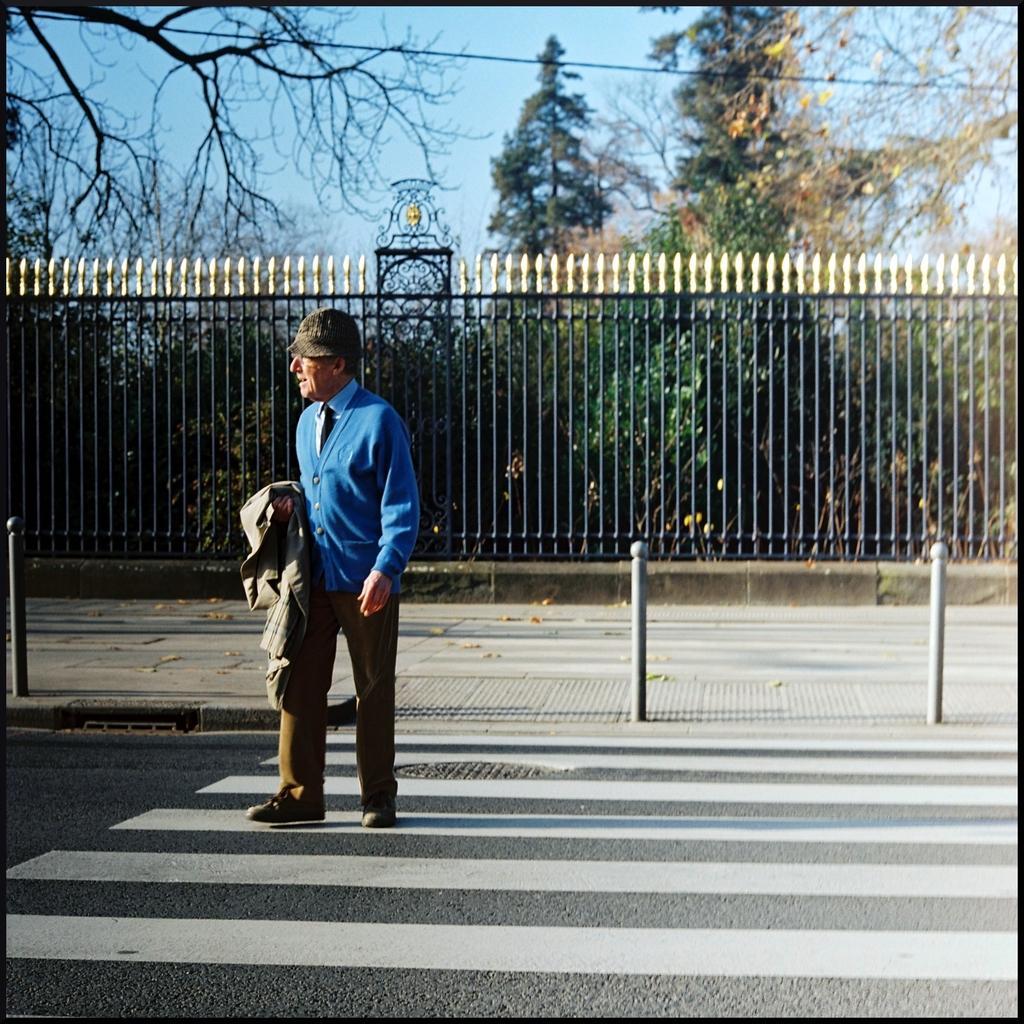Describe this image in one or two sentences. In the middle I can see a person on the road. In the background I can see a fence, trees and wires. On the top I can see the sky. This image is taken during a sunny day. 